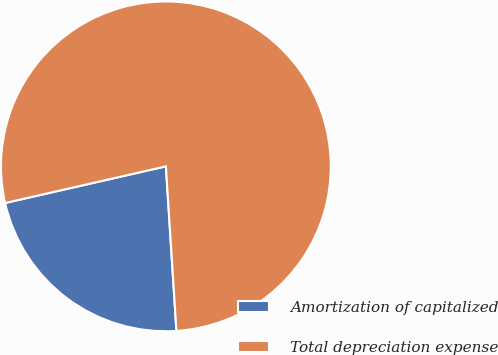Convert chart. <chart><loc_0><loc_0><loc_500><loc_500><pie_chart><fcel>Amortization of capitalized<fcel>Total depreciation expense<nl><fcel>22.45%<fcel>77.55%<nl></chart> 